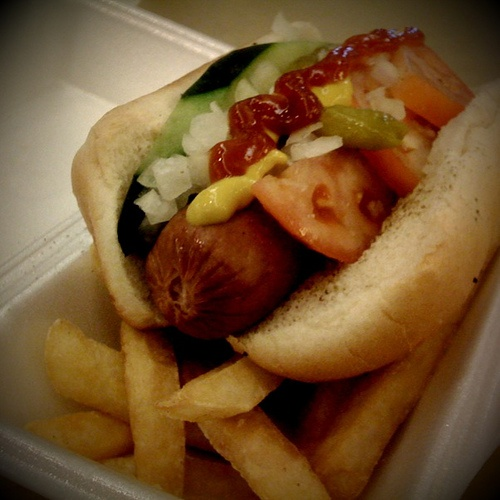Describe the objects in this image and their specific colors. I can see a hot dog in black, maroon, olive, and tan tones in this image. 